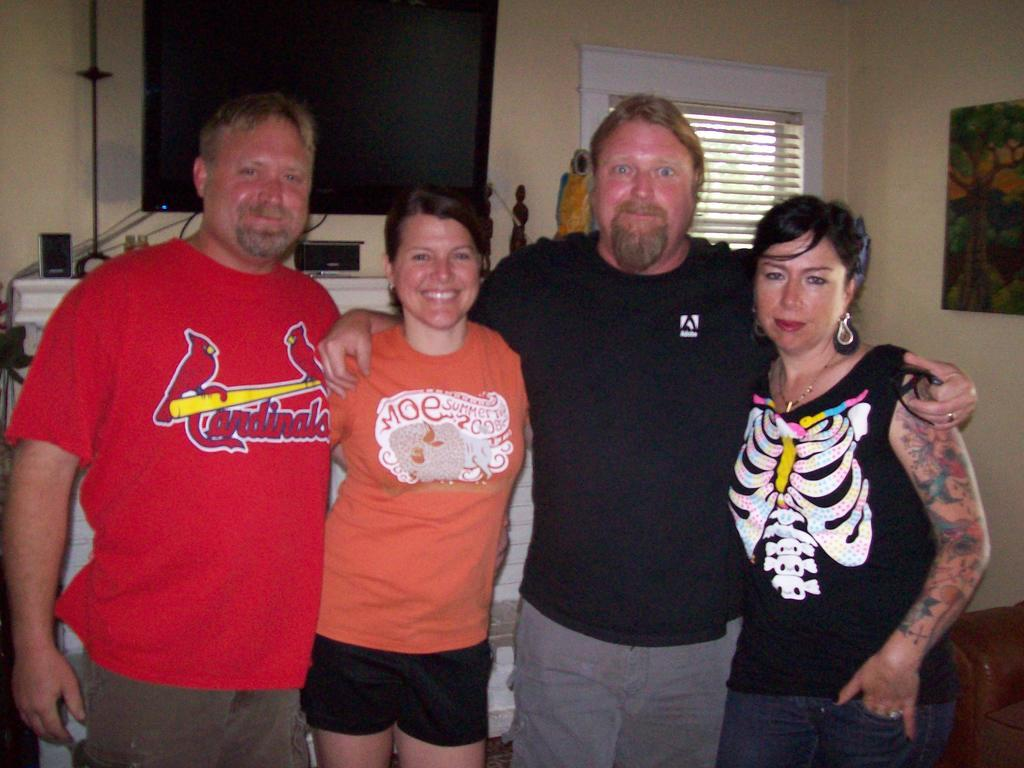Provide a one-sentence caption for the provided image. A man in a Cardinals t-shirt poses with three other people. 